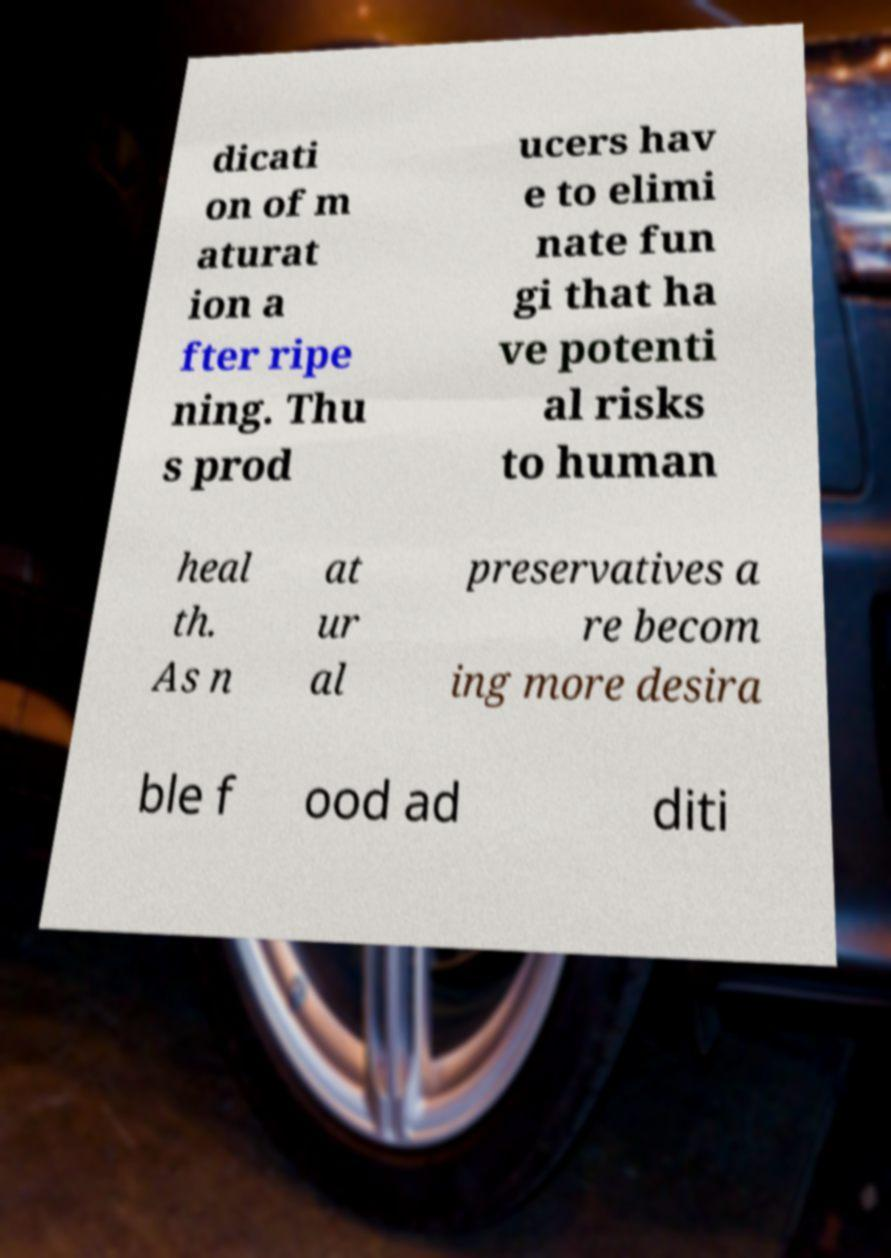Can you accurately transcribe the text from the provided image for me? dicati on of m aturat ion a fter ripe ning. Thu s prod ucers hav e to elimi nate fun gi that ha ve potenti al risks to human heal th. As n at ur al preservatives a re becom ing more desira ble f ood ad diti 